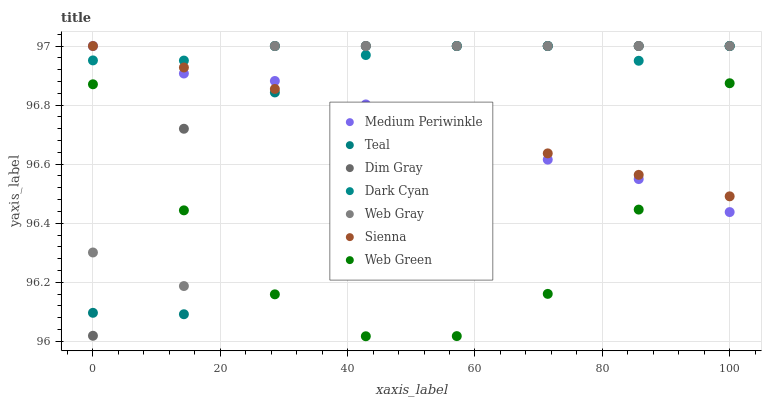Does Web Green have the minimum area under the curve?
Answer yes or no. Yes. Does Dark Cyan have the maximum area under the curve?
Answer yes or no. Yes. Does Medium Periwinkle have the minimum area under the curve?
Answer yes or no. No. Does Medium Periwinkle have the maximum area under the curve?
Answer yes or no. No. Is Sienna the smoothest?
Answer yes or no. Yes. Is Web Gray the roughest?
Answer yes or no. Yes. Is Medium Periwinkle the smoothest?
Answer yes or no. No. Is Medium Periwinkle the roughest?
Answer yes or no. No. Does Web Green have the lowest value?
Answer yes or no. Yes. Does Medium Periwinkle have the lowest value?
Answer yes or no. No. Does Dark Cyan have the highest value?
Answer yes or no. Yes. Does Web Green have the highest value?
Answer yes or no. No. Is Web Green less than Dark Cyan?
Answer yes or no. Yes. Is Dark Cyan greater than Web Green?
Answer yes or no. Yes. Does Dim Gray intersect Dark Cyan?
Answer yes or no. Yes. Is Dim Gray less than Dark Cyan?
Answer yes or no. No. Is Dim Gray greater than Dark Cyan?
Answer yes or no. No. Does Web Green intersect Dark Cyan?
Answer yes or no. No. 